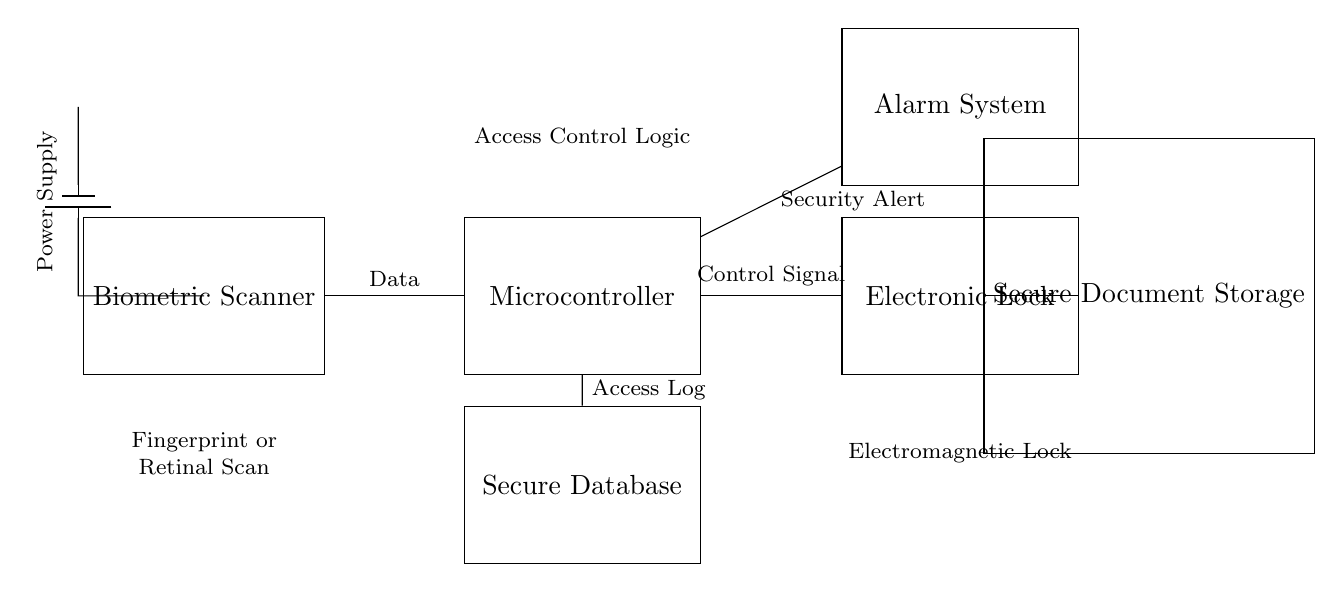What is the type of biometric input used in this system? The system uses either a fingerprint or retinal scan as indicated in the labels attached to the biometric scanner component.
Answer: Fingerprint or retinal scan What component processes data from the biometric scanner? The circuit shows a connection from the biometric scanner to a microcontroller, which is responsible for processing the data.
Answer: Microcontroller What is the role of the electronic lock in this circuit? The electronic lock receives a control signal from the microcontroller that allows or prevents access to the secure document storage.
Answer: Access control Where does the access log data get stored? The access log data flows from the microcontroller to a secure database as indicated by the direct connection shown in the circuit diagram.
Answer: Secure database What triggers the alarm system? The alarm system is triggered by a security alert signal from the microcontroller, indicating a potential breach or unauthorized access attempt.
Answer: Security alert How does the biometric scanner affect circuit security? The biometric scanner verifies user identity before allowing access, significantly enhancing overall circuit security by ensuring that unauthorized users cannot open the electronic lock.
Answer: Enhances security What component provides power to the entire circuit? A battery is depicted in the circuit diagram, which supplies power to the biometric scanner and other components of the circuit.
Answer: Battery 